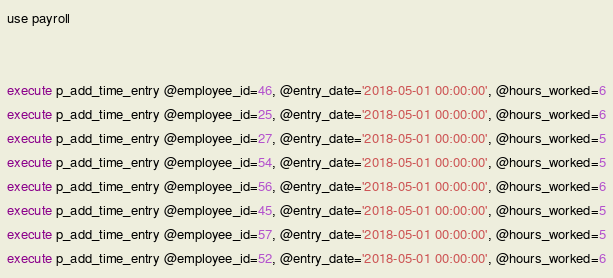<code> <loc_0><loc_0><loc_500><loc_500><_SQL_>use payroll


execute p_add_time_entry @employee_id=46, @entry_date='2018-05-01 00:00:00', @hours_worked=6
execute p_add_time_entry @employee_id=25, @entry_date='2018-05-01 00:00:00', @hours_worked=6
execute p_add_time_entry @employee_id=27, @entry_date='2018-05-01 00:00:00', @hours_worked=5
execute p_add_time_entry @employee_id=54, @entry_date='2018-05-01 00:00:00', @hours_worked=5
execute p_add_time_entry @employee_id=56, @entry_date='2018-05-01 00:00:00', @hours_worked=6
execute p_add_time_entry @employee_id=45, @entry_date='2018-05-01 00:00:00', @hours_worked=5
execute p_add_time_entry @employee_id=57, @entry_date='2018-05-01 00:00:00', @hours_worked=5
execute p_add_time_entry @employee_id=52, @entry_date='2018-05-01 00:00:00', @hours_worked=6

</code> 